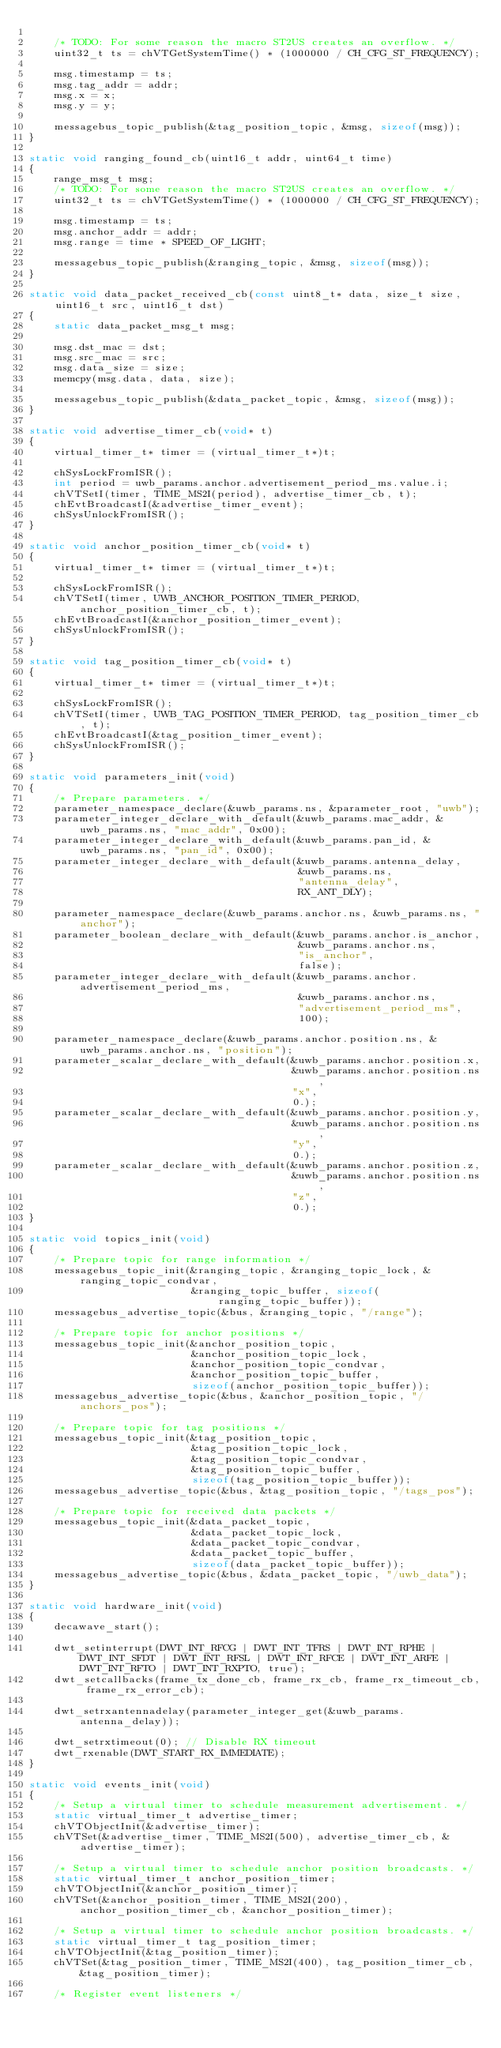Convert code to text. <code><loc_0><loc_0><loc_500><loc_500><_C_>
    /* TODO: For some reason the macro ST2US creates an overflow. */
    uint32_t ts = chVTGetSystemTime() * (1000000 / CH_CFG_ST_FREQUENCY);

    msg.timestamp = ts;
    msg.tag_addr = addr;
    msg.x = x;
    msg.y = y;

    messagebus_topic_publish(&tag_position_topic, &msg, sizeof(msg));
}

static void ranging_found_cb(uint16_t addr, uint64_t time)
{
    range_msg_t msg;
    /* TODO: For some reason the macro ST2US creates an overflow. */
    uint32_t ts = chVTGetSystemTime() * (1000000 / CH_CFG_ST_FREQUENCY);

    msg.timestamp = ts;
    msg.anchor_addr = addr;
    msg.range = time * SPEED_OF_LIGHT;

    messagebus_topic_publish(&ranging_topic, &msg, sizeof(msg));
}

static void data_packet_received_cb(const uint8_t* data, size_t size, uint16_t src, uint16_t dst)
{
    static data_packet_msg_t msg;

    msg.dst_mac = dst;
    msg.src_mac = src;
    msg.data_size = size;
    memcpy(msg.data, data, size);

    messagebus_topic_publish(&data_packet_topic, &msg, sizeof(msg));
}

static void advertise_timer_cb(void* t)
{
    virtual_timer_t* timer = (virtual_timer_t*)t;

    chSysLockFromISR();
    int period = uwb_params.anchor.advertisement_period_ms.value.i;
    chVTSetI(timer, TIME_MS2I(period), advertise_timer_cb, t);
    chEvtBroadcastI(&advertise_timer_event);
    chSysUnlockFromISR();
}

static void anchor_position_timer_cb(void* t)
{
    virtual_timer_t* timer = (virtual_timer_t*)t;

    chSysLockFromISR();
    chVTSetI(timer, UWB_ANCHOR_POSITION_TIMER_PERIOD, anchor_position_timer_cb, t);
    chEvtBroadcastI(&anchor_position_timer_event);
    chSysUnlockFromISR();
}

static void tag_position_timer_cb(void* t)
{
    virtual_timer_t* timer = (virtual_timer_t*)t;

    chSysLockFromISR();
    chVTSetI(timer, UWB_TAG_POSITION_TIMER_PERIOD, tag_position_timer_cb, t);
    chEvtBroadcastI(&tag_position_timer_event);
    chSysUnlockFromISR();
}

static void parameters_init(void)
{
    /* Prepare parameters. */
    parameter_namespace_declare(&uwb_params.ns, &parameter_root, "uwb");
    parameter_integer_declare_with_default(&uwb_params.mac_addr, &uwb_params.ns, "mac_addr", 0x00);
    parameter_integer_declare_with_default(&uwb_params.pan_id, &uwb_params.ns, "pan_id", 0x00);
    parameter_integer_declare_with_default(&uwb_params.antenna_delay,
                                           &uwb_params.ns,
                                           "antenna_delay",
                                           RX_ANT_DLY);

    parameter_namespace_declare(&uwb_params.anchor.ns, &uwb_params.ns, "anchor");
    parameter_boolean_declare_with_default(&uwb_params.anchor.is_anchor,
                                           &uwb_params.anchor.ns,
                                           "is_anchor",
                                           false);
    parameter_integer_declare_with_default(&uwb_params.anchor.advertisement_period_ms,
                                           &uwb_params.anchor.ns,
                                           "advertisement_period_ms",
                                           100);

    parameter_namespace_declare(&uwb_params.anchor.position.ns, &uwb_params.anchor.ns, "position");
    parameter_scalar_declare_with_default(&uwb_params.anchor.position.x,
                                          &uwb_params.anchor.position.ns,
                                          "x",
                                          0.);
    parameter_scalar_declare_with_default(&uwb_params.anchor.position.y,
                                          &uwb_params.anchor.position.ns,
                                          "y",
                                          0.);
    parameter_scalar_declare_with_default(&uwb_params.anchor.position.z,
                                          &uwb_params.anchor.position.ns,
                                          "z",
                                          0.);
}

static void topics_init(void)
{
    /* Prepare topic for range information */
    messagebus_topic_init(&ranging_topic, &ranging_topic_lock, &ranging_topic_condvar,
                          &ranging_topic_buffer, sizeof(ranging_topic_buffer));
    messagebus_advertise_topic(&bus, &ranging_topic, "/range");

    /* Prepare topic for anchor positions */
    messagebus_topic_init(&anchor_position_topic,
                          &anchor_position_topic_lock,
                          &anchor_position_topic_condvar,
                          &anchor_position_topic_buffer,
                          sizeof(anchor_position_topic_buffer));
    messagebus_advertise_topic(&bus, &anchor_position_topic, "/anchors_pos");

    /* Prepare topic for tag positions */
    messagebus_topic_init(&tag_position_topic,
                          &tag_position_topic_lock,
                          &tag_position_topic_condvar,
                          &tag_position_topic_buffer,
                          sizeof(tag_position_topic_buffer));
    messagebus_advertise_topic(&bus, &tag_position_topic, "/tags_pos");

    /* Prepare topic for received data packets */
    messagebus_topic_init(&data_packet_topic,
                          &data_packet_topic_lock,
                          &data_packet_topic_condvar,
                          &data_packet_topic_buffer,
                          sizeof(data_packet_topic_buffer));
    messagebus_advertise_topic(&bus, &data_packet_topic, "/uwb_data");
}

static void hardware_init(void)
{
    decawave_start();

    dwt_setinterrupt(DWT_INT_RFCG | DWT_INT_TFRS | DWT_INT_RPHE | DWT_INT_SFDT | DWT_INT_RFSL | DWT_INT_RFCE | DWT_INT_ARFE | DWT_INT_RFTO | DWT_INT_RXPTO, true);
    dwt_setcallbacks(frame_tx_done_cb, frame_rx_cb, frame_rx_timeout_cb, frame_rx_error_cb);

    dwt_setrxantennadelay(parameter_integer_get(&uwb_params.antenna_delay));

    dwt_setrxtimeout(0); // Disable RX timeout
    dwt_rxenable(DWT_START_RX_IMMEDIATE);
}

static void events_init(void)
{
    /* Setup a virtual timer to schedule measurement advertisement. */
    static virtual_timer_t advertise_timer;
    chVTObjectInit(&advertise_timer);
    chVTSet(&advertise_timer, TIME_MS2I(500), advertise_timer_cb, &advertise_timer);

    /* Setup a virtual timer to schedule anchor position broadcasts. */
    static virtual_timer_t anchor_position_timer;
    chVTObjectInit(&anchor_position_timer);
    chVTSet(&anchor_position_timer, TIME_MS2I(200), anchor_position_timer_cb, &anchor_position_timer);

    /* Setup a virtual timer to schedule anchor position broadcasts. */
    static virtual_timer_t tag_position_timer;
    chVTObjectInit(&tag_position_timer);
    chVTSet(&tag_position_timer, TIME_MS2I(400), tag_position_timer_cb, &tag_position_timer);

    /* Register event listeners */</code> 